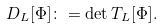Convert formula to latex. <formula><loc_0><loc_0><loc_500><loc_500>D _ { L } [ \Phi ] \colon = \det T _ { L } [ \Phi ] .</formula> 